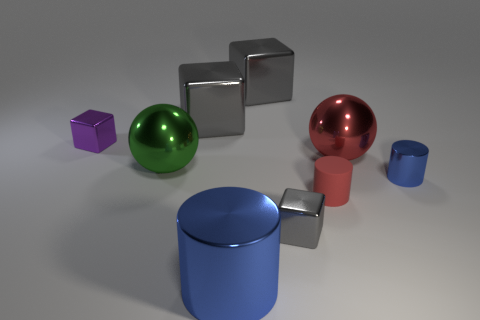How many big blue things are there?
Your response must be concise. 1. Are there any gray cubes of the same size as the red shiny sphere?
Ensure brevity in your answer.  Yes. Are the purple block and the sphere on the left side of the large cylinder made of the same material?
Your response must be concise. Yes. There is a red object in front of the large green metal ball; what is it made of?
Your response must be concise. Rubber. What size is the green ball?
Your answer should be very brief. Large. Is the size of the blue cylinder left of the tiny blue metal cylinder the same as the red object that is in front of the big green metal sphere?
Provide a short and direct response. No. The other metallic object that is the same shape as the big green metal object is what size?
Give a very brief answer. Large. Does the rubber cylinder have the same size as the blue cylinder that is on the left side of the red sphere?
Offer a very short reply. No. Are there any tiny gray shiny things behind the big thing to the right of the tiny matte thing?
Offer a terse response. No. What shape is the gray shiny object in front of the purple metallic cube?
Ensure brevity in your answer.  Cube. 